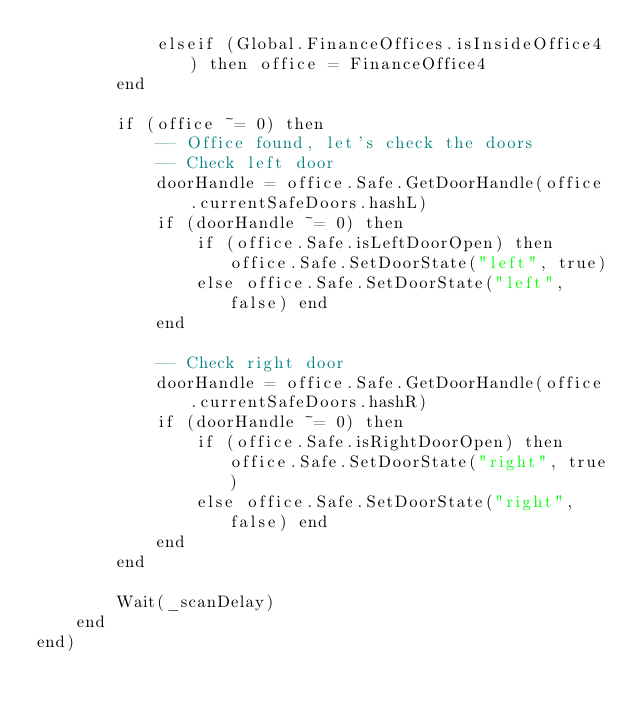Convert code to text. <code><loc_0><loc_0><loc_500><loc_500><_Lua_>            elseif (Global.FinanceOffices.isInsideOffice4) then office = FinanceOffice4
        end

        if (office ~= 0) then
            -- Office found, let's check the doors
            -- Check left door
            doorHandle = office.Safe.GetDoorHandle(office.currentSafeDoors.hashL)
            if (doorHandle ~= 0) then
                if (office.Safe.isLeftDoorOpen) then office.Safe.SetDoorState("left", true)
                else office.Safe.SetDoorState("left", false) end
            end

            -- Check right door
            doorHandle = office.Safe.GetDoorHandle(office.currentSafeDoors.hashR)
            if (doorHandle ~= 0) then
                if (office.Safe.isRightDoorOpen) then office.Safe.SetDoorState("right", true)
                else office.Safe.SetDoorState("right", false) end
            end
        end

        Wait(_scanDelay)
    end
end)
</code> 